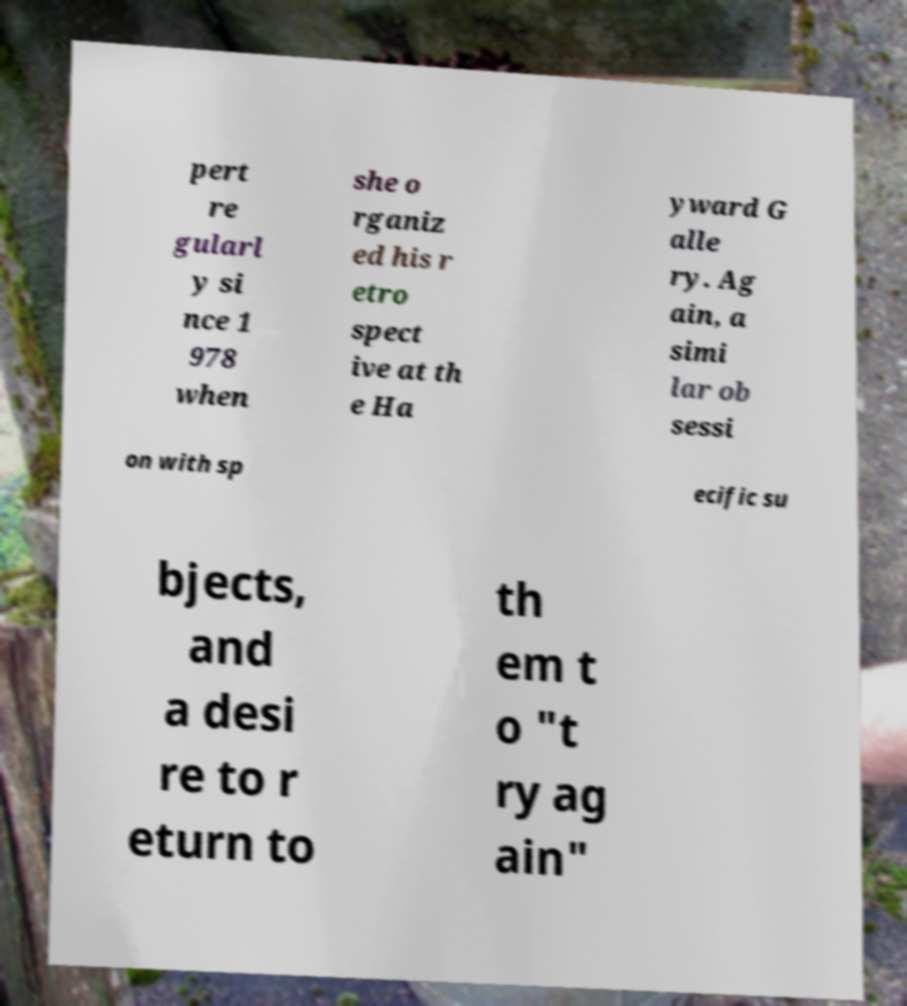Could you assist in decoding the text presented in this image and type it out clearly? pert re gularl y si nce 1 978 when she o rganiz ed his r etro spect ive at th e Ha yward G alle ry. Ag ain, a simi lar ob sessi on with sp ecific su bjects, and a desi re to r eturn to th em t o "t ry ag ain" 